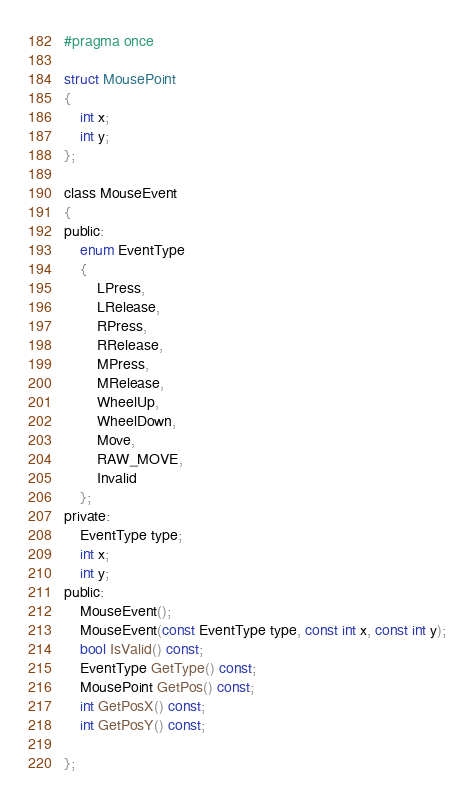Convert code to text. <code><loc_0><loc_0><loc_500><loc_500><_C_>#pragma once

struct MousePoint
{
	int x;
	int y;
};

class MouseEvent
{
public:
	enum EventType
	{
		LPress,
		LRelease,
		RPress,
		RRelease,
		MPress,
		MRelease,
		WheelUp,
		WheelDown,
		Move,
		RAW_MOVE,
		Invalid
	};
private:
	EventType type;
	int x;
	int y;
public:
	MouseEvent();
	MouseEvent(const EventType type, const int x, const int y);
	bool IsValid() const;
	EventType GetType() const;
	MousePoint GetPos() const;
	int GetPosX() const;
	int GetPosY() const;

};</code> 